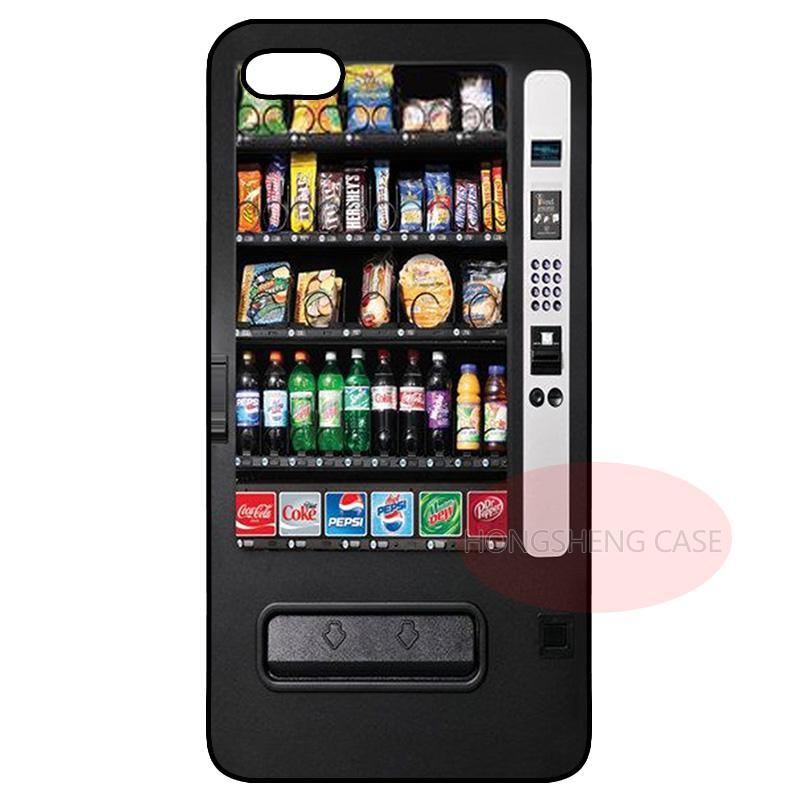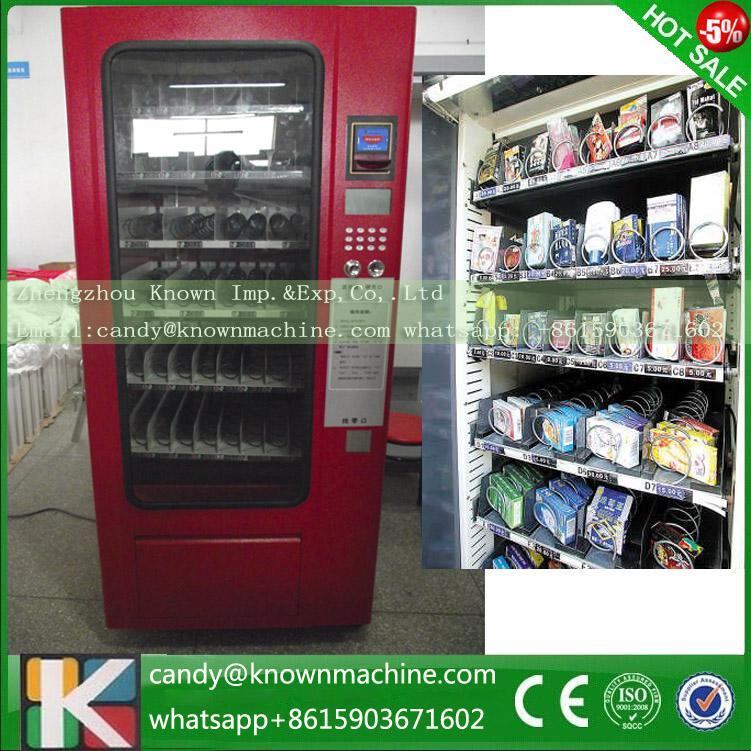The first image is the image on the left, the second image is the image on the right. For the images displayed, is the sentence "In one image, a vending machine unit has a central payment panel with equal sized vending machines on each side with six shelves each." factually correct? Answer yes or no. No. The first image is the image on the left, the second image is the image on the right. For the images displayed, is the sentence "There are more machines in the image on the left than in the image on the right." factually correct? Answer yes or no. No. 